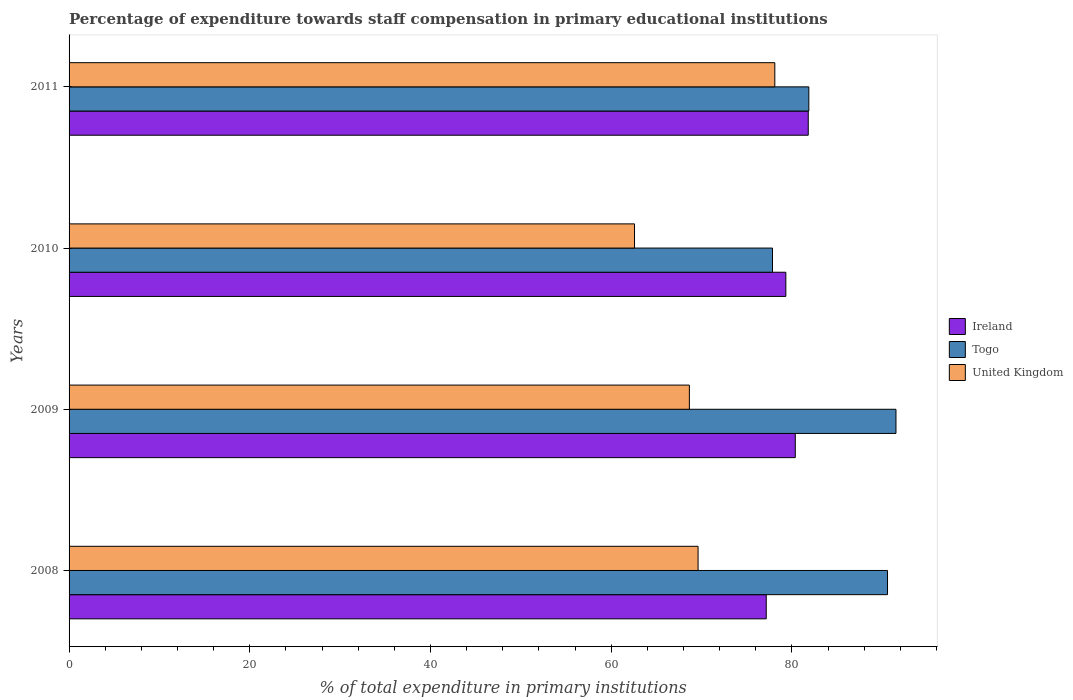How many different coloured bars are there?
Provide a succinct answer. 3. Are the number of bars per tick equal to the number of legend labels?
Your answer should be very brief. Yes. How many bars are there on the 1st tick from the top?
Offer a very short reply. 3. In how many cases, is the number of bars for a given year not equal to the number of legend labels?
Offer a terse response. 0. What is the percentage of expenditure towards staff compensation in United Kingdom in 2009?
Offer a terse response. 68.65. Across all years, what is the maximum percentage of expenditure towards staff compensation in United Kingdom?
Make the answer very short. 78.1. Across all years, what is the minimum percentage of expenditure towards staff compensation in United Kingdom?
Offer a terse response. 62.58. What is the total percentage of expenditure towards staff compensation in Ireland in the graph?
Offer a terse response. 318.64. What is the difference between the percentage of expenditure towards staff compensation in United Kingdom in 2009 and that in 2010?
Ensure brevity in your answer.  6.07. What is the difference between the percentage of expenditure towards staff compensation in Ireland in 2010 and the percentage of expenditure towards staff compensation in United Kingdom in 2009?
Your answer should be very brief. 10.68. What is the average percentage of expenditure towards staff compensation in Togo per year?
Provide a short and direct response. 85.45. In the year 2011, what is the difference between the percentage of expenditure towards staff compensation in Togo and percentage of expenditure towards staff compensation in United Kingdom?
Keep it short and to the point. 3.76. What is the ratio of the percentage of expenditure towards staff compensation in United Kingdom in 2008 to that in 2009?
Keep it short and to the point. 1.01. Is the difference between the percentage of expenditure towards staff compensation in Togo in 2008 and 2011 greater than the difference between the percentage of expenditure towards staff compensation in United Kingdom in 2008 and 2011?
Offer a very short reply. Yes. What is the difference between the highest and the second highest percentage of expenditure towards staff compensation in United Kingdom?
Provide a succinct answer. 8.49. What is the difference between the highest and the lowest percentage of expenditure towards staff compensation in Togo?
Offer a terse response. 13.66. What does the 3rd bar from the top in 2011 represents?
Provide a succinct answer. Ireland. What does the 1st bar from the bottom in 2011 represents?
Make the answer very short. Ireland. Is it the case that in every year, the sum of the percentage of expenditure towards staff compensation in Togo and percentage of expenditure towards staff compensation in Ireland is greater than the percentage of expenditure towards staff compensation in United Kingdom?
Ensure brevity in your answer.  Yes. How many years are there in the graph?
Offer a very short reply. 4. Are the values on the major ticks of X-axis written in scientific E-notation?
Provide a short and direct response. No. Does the graph contain any zero values?
Your answer should be compact. No. Does the graph contain grids?
Offer a very short reply. No. What is the title of the graph?
Provide a succinct answer. Percentage of expenditure towards staff compensation in primary educational institutions. Does "Algeria" appear as one of the legend labels in the graph?
Your answer should be very brief. No. What is the label or title of the X-axis?
Your answer should be compact. % of total expenditure in primary institutions. What is the % of total expenditure in primary institutions of Ireland in 2008?
Your answer should be very brief. 77.15. What is the % of total expenditure in primary institutions of Togo in 2008?
Offer a terse response. 90.57. What is the % of total expenditure in primary institutions in United Kingdom in 2008?
Provide a short and direct response. 69.61. What is the % of total expenditure in primary institutions of Ireland in 2009?
Your response must be concise. 80.37. What is the % of total expenditure in primary institutions of Togo in 2009?
Offer a terse response. 91.51. What is the % of total expenditure in primary institutions in United Kingdom in 2009?
Give a very brief answer. 68.65. What is the % of total expenditure in primary institutions of Ireland in 2010?
Provide a short and direct response. 79.32. What is the % of total expenditure in primary institutions in Togo in 2010?
Your answer should be very brief. 77.85. What is the % of total expenditure in primary institutions in United Kingdom in 2010?
Provide a short and direct response. 62.58. What is the % of total expenditure in primary institutions of Ireland in 2011?
Make the answer very short. 81.8. What is the % of total expenditure in primary institutions in Togo in 2011?
Give a very brief answer. 81.87. What is the % of total expenditure in primary institutions of United Kingdom in 2011?
Provide a succinct answer. 78.1. Across all years, what is the maximum % of total expenditure in primary institutions of Ireland?
Ensure brevity in your answer.  81.8. Across all years, what is the maximum % of total expenditure in primary institutions of Togo?
Give a very brief answer. 91.51. Across all years, what is the maximum % of total expenditure in primary institutions in United Kingdom?
Your answer should be compact. 78.1. Across all years, what is the minimum % of total expenditure in primary institutions of Ireland?
Your response must be concise. 77.15. Across all years, what is the minimum % of total expenditure in primary institutions in Togo?
Keep it short and to the point. 77.85. Across all years, what is the minimum % of total expenditure in primary institutions in United Kingdom?
Your answer should be compact. 62.58. What is the total % of total expenditure in primary institutions in Ireland in the graph?
Make the answer very short. 318.64. What is the total % of total expenditure in primary institutions in Togo in the graph?
Provide a short and direct response. 341.8. What is the total % of total expenditure in primary institutions in United Kingdom in the graph?
Your answer should be compact. 278.93. What is the difference between the % of total expenditure in primary institutions of Ireland in 2008 and that in 2009?
Provide a succinct answer. -3.21. What is the difference between the % of total expenditure in primary institutions in Togo in 2008 and that in 2009?
Ensure brevity in your answer.  -0.94. What is the difference between the % of total expenditure in primary institutions in United Kingdom in 2008 and that in 2009?
Your response must be concise. 0.96. What is the difference between the % of total expenditure in primary institutions of Ireland in 2008 and that in 2010?
Ensure brevity in your answer.  -2.17. What is the difference between the % of total expenditure in primary institutions in Togo in 2008 and that in 2010?
Provide a succinct answer. 12.73. What is the difference between the % of total expenditure in primary institutions of United Kingdom in 2008 and that in 2010?
Keep it short and to the point. 7.03. What is the difference between the % of total expenditure in primary institutions of Ireland in 2008 and that in 2011?
Offer a very short reply. -4.65. What is the difference between the % of total expenditure in primary institutions of Togo in 2008 and that in 2011?
Your response must be concise. 8.71. What is the difference between the % of total expenditure in primary institutions in United Kingdom in 2008 and that in 2011?
Make the answer very short. -8.49. What is the difference between the % of total expenditure in primary institutions of Ireland in 2009 and that in 2010?
Ensure brevity in your answer.  1.04. What is the difference between the % of total expenditure in primary institutions of Togo in 2009 and that in 2010?
Make the answer very short. 13.66. What is the difference between the % of total expenditure in primary institutions in United Kingdom in 2009 and that in 2010?
Keep it short and to the point. 6.07. What is the difference between the % of total expenditure in primary institutions of Ireland in 2009 and that in 2011?
Give a very brief answer. -1.43. What is the difference between the % of total expenditure in primary institutions of Togo in 2009 and that in 2011?
Your response must be concise. 9.64. What is the difference between the % of total expenditure in primary institutions of United Kingdom in 2009 and that in 2011?
Your answer should be compact. -9.46. What is the difference between the % of total expenditure in primary institutions in Ireland in 2010 and that in 2011?
Give a very brief answer. -2.48. What is the difference between the % of total expenditure in primary institutions of Togo in 2010 and that in 2011?
Provide a succinct answer. -4.02. What is the difference between the % of total expenditure in primary institutions in United Kingdom in 2010 and that in 2011?
Make the answer very short. -15.53. What is the difference between the % of total expenditure in primary institutions in Ireland in 2008 and the % of total expenditure in primary institutions in Togo in 2009?
Provide a succinct answer. -14.36. What is the difference between the % of total expenditure in primary institutions in Ireland in 2008 and the % of total expenditure in primary institutions in United Kingdom in 2009?
Offer a very short reply. 8.51. What is the difference between the % of total expenditure in primary institutions of Togo in 2008 and the % of total expenditure in primary institutions of United Kingdom in 2009?
Keep it short and to the point. 21.93. What is the difference between the % of total expenditure in primary institutions of Ireland in 2008 and the % of total expenditure in primary institutions of Togo in 2010?
Give a very brief answer. -0.69. What is the difference between the % of total expenditure in primary institutions of Ireland in 2008 and the % of total expenditure in primary institutions of United Kingdom in 2010?
Your answer should be compact. 14.58. What is the difference between the % of total expenditure in primary institutions of Togo in 2008 and the % of total expenditure in primary institutions of United Kingdom in 2010?
Give a very brief answer. 28. What is the difference between the % of total expenditure in primary institutions in Ireland in 2008 and the % of total expenditure in primary institutions in Togo in 2011?
Provide a short and direct response. -4.71. What is the difference between the % of total expenditure in primary institutions in Ireland in 2008 and the % of total expenditure in primary institutions in United Kingdom in 2011?
Offer a very short reply. -0.95. What is the difference between the % of total expenditure in primary institutions in Togo in 2008 and the % of total expenditure in primary institutions in United Kingdom in 2011?
Offer a very short reply. 12.47. What is the difference between the % of total expenditure in primary institutions in Ireland in 2009 and the % of total expenditure in primary institutions in Togo in 2010?
Provide a short and direct response. 2.52. What is the difference between the % of total expenditure in primary institutions of Ireland in 2009 and the % of total expenditure in primary institutions of United Kingdom in 2010?
Make the answer very short. 17.79. What is the difference between the % of total expenditure in primary institutions of Togo in 2009 and the % of total expenditure in primary institutions of United Kingdom in 2010?
Ensure brevity in your answer.  28.93. What is the difference between the % of total expenditure in primary institutions of Ireland in 2009 and the % of total expenditure in primary institutions of Togo in 2011?
Make the answer very short. -1.5. What is the difference between the % of total expenditure in primary institutions in Ireland in 2009 and the % of total expenditure in primary institutions in United Kingdom in 2011?
Offer a very short reply. 2.26. What is the difference between the % of total expenditure in primary institutions in Togo in 2009 and the % of total expenditure in primary institutions in United Kingdom in 2011?
Provide a succinct answer. 13.41. What is the difference between the % of total expenditure in primary institutions in Ireland in 2010 and the % of total expenditure in primary institutions in Togo in 2011?
Give a very brief answer. -2.54. What is the difference between the % of total expenditure in primary institutions in Ireland in 2010 and the % of total expenditure in primary institutions in United Kingdom in 2011?
Provide a short and direct response. 1.22. What is the difference between the % of total expenditure in primary institutions in Togo in 2010 and the % of total expenditure in primary institutions in United Kingdom in 2011?
Offer a very short reply. -0.26. What is the average % of total expenditure in primary institutions of Ireland per year?
Offer a very short reply. 79.66. What is the average % of total expenditure in primary institutions of Togo per year?
Provide a short and direct response. 85.45. What is the average % of total expenditure in primary institutions in United Kingdom per year?
Offer a terse response. 69.73. In the year 2008, what is the difference between the % of total expenditure in primary institutions in Ireland and % of total expenditure in primary institutions in Togo?
Offer a very short reply. -13.42. In the year 2008, what is the difference between the % of total expenditure in primary institutions in Ireland and % of total expenditure in primary institutions in United Kingdom?
Ensure brevity in your answer.  7.54. In the year 2008, what is the difference between the % of total expenditure in primary institutions of Togo and % of total expenditure in primary institutions of United Kingdom?
Ensure brevity in your answer.  20.96. In the year 2009, what is the difference between the % of total expenditure in primary institutions of Ireland and % of total expenditure in primary institutions of Togo?
Give a very brief answer. -11.14. In the year 2009, what is the difference between the % of total expenditure in primary institutions in Ireland and % of total expenditure in primary institutions in United Kingdom?
Your response must be concise. 11.72. In the year 2009, what is the difference between the % of total expenditure in primary institutions of Togo and % of total expenditure in primary institutions of United Kingdom?
Provide a short and direct response. 22.86. In the year 2010, what is the difference between the % of total expenditure in primary institutions of Ireland and % of total expenditure in primary institutions of Togo?
Your response must be concise. 1.48. In the year 2010, what is the difference between the % of total expenditure in primary institutions in Ireland and % of total expenditure in primary institutions in United Kingdom?
Give a very brief answer. 16.75. In the year 2010, what is the difference between the % of total expenditure in primary institutions in Togo and % of total expenditure in primary institutions in United Kingdom?
Your answer should be compact. 15.27. In the year 2011, what is the difference between the % of total expenditure in primary institutions of Ireland and % of total expenditure in primary institutions of Togo?
Offer a very short reply. -0.06. In the year 2011, what is the difference between the % of total expenditure in primary institutions of Ireland and % of total expenditure in primary institutions of United Kingdom?
Offer a very short reply. 3.7. In the year 2011, what is the difference between the % of total expenditure in primary institutions in Togo and % of total expenditure in primary institutions in United Kingdom?
Your answer should be very brief. 3.76. What is the ratio of the % of total expenditure in primary institutions of Ireland in 2008 to that in 2009?
Ensure brevity in your answer.  0.96. What is the ratio of the % of total expenditure in primary institutions in Ireland in 2008 to that in 2010?
Offer a very short reply. 0.97. What is the ratio of the % of total expenditure in primary institutions of Togo in 2008 to that in 2010?
Make the answer very short. 1.16. What is the ratio of the % of total expenditure in primary institutions in United Kingdom in 2008 to that in 2010?
Provide a short and direct response. 1.11. What is the ratio of the % of total expenditure in primary institutions in Ireland in 2008 to that in 2011?
Ensure brevity in your answer.  0.94. What is the ratio of the % of total expenditure in primary institutions in Togo in 2008 to that in 2011?
Give a very brief answer. 1.11. What is the ratio of the % of total expenditure in primary institutions of United Kingdom in 2008 to that in 2011?
Ensure brevity in your answer.  0.89. What is the ratio of the % of total expenditure in primary institutions of Ireland in 2009 to that in 2010?
Provide a succinct answer. 1.01. What is the ratio of the % of total expenditure in primary institutions of Togo in 2009 to that in 2010?
Offer a terse response. 1.18. What is the ratio of the % of total expenditure in primary institutions of United Kingdom in 2009 to that in 2010?
Your response must be concise. 1.1. What is the ratio of the % of total expenditure in primary institutions of Ireland in 2009 to that in 2011?
Your answer should be very brief. 0.98. What is the ratio of the % of total expenditure in primary institutions in Togo in 2009 to that in 2011?
Your answer should be very brief. 1.12. What is the ratio of the % of total expenditure in primary institutions of United Kingdom in 2009 to that in 2011?
Keep it short and to the point. 0.88. What is the ratio of the % of total expenditure in primary institutions in Ireland in 2010 to that in 2011?
Your answer should be very brief. 0.97. What is the ratio of the % of total expenditure in primary institutions of Togo in 2010 to that in 2011?
Your answer should be compact. 0.95. What is the ratio of the % of total expenditure in primary institutions of United Kingdom in 2010 to that in 2011?
Your answer should be compact. 0.8. What is the difference between the highest and the second highest % of total expenditure in primary institutions of Ireland?
Offer a very short reply. 1.43. What is the difference between the highest and the second highest % of total expenditure in primary institutions in Togo?
Your answer should be compact. 0.94. What is the difference between the highest and the second highest % of total expenditure in primary institutions of United Kingdom?
Make the answer very short. 8.49. What is the difference between the highest and the lowest % of total expenditure in primary institutions in Ireland?
Ensure brevity in your answer.  4.65. What is the difference between the highest and the lowest % of total expenditure in primary institutions in Togo?
Make the answer very short. 13.66. What is the difference between the highest and the lowest % of total expenditure in primary institutions of United Kingdom?
Offer a very short reply. 15.53. 